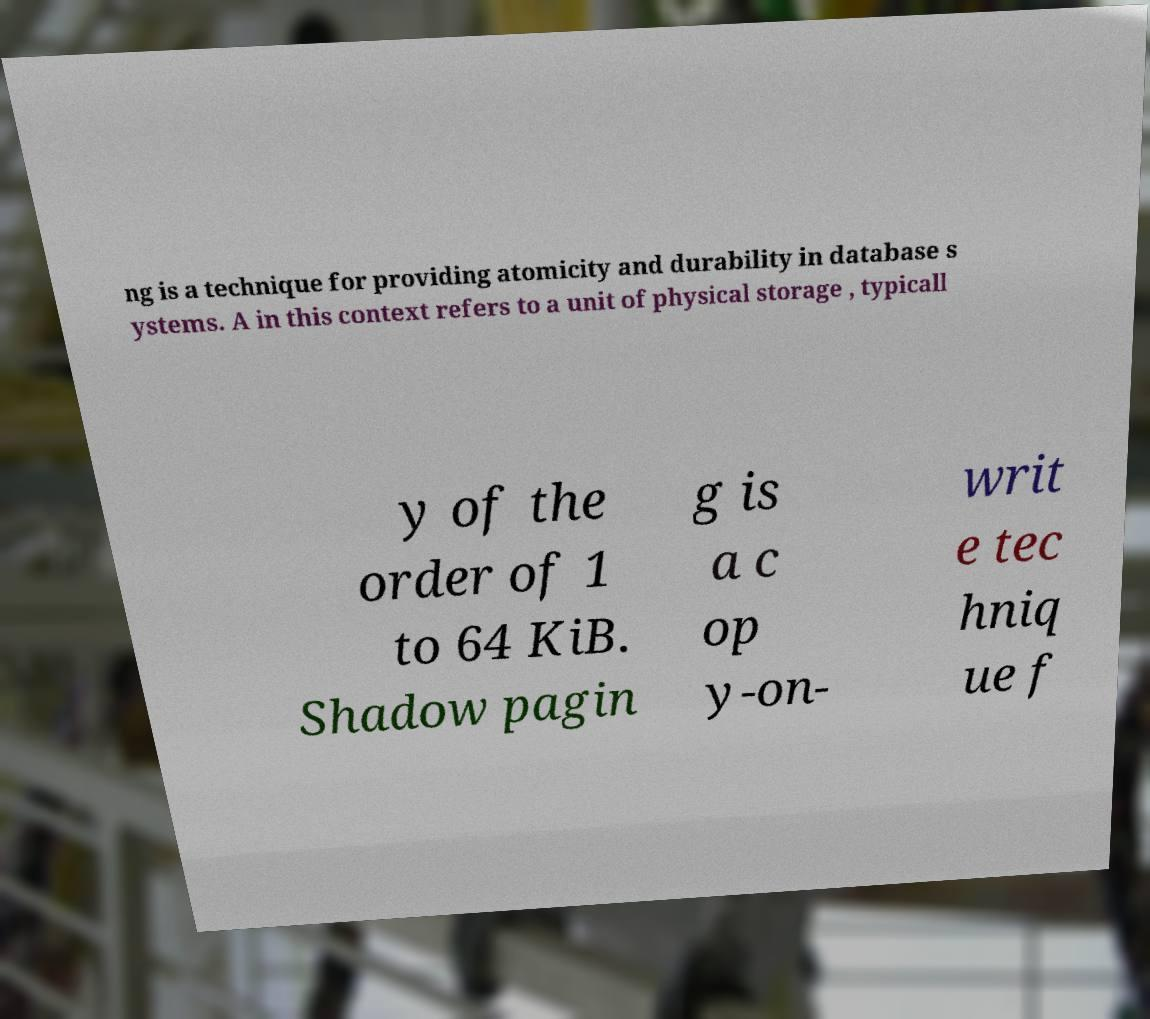Can you read and provide the text displayed in the image?This photo seems to have some interesting text. Can you extract and type it out for me? ng is a technique for providing atomicity and durability in database s ystems. A in this context refers to a unit of physical storage , typicall y of the order of 1 to 64 KiB. Shadow pagin g is a c op y-on- writ e tec hniq ue f 